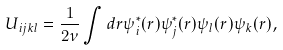Convert formula to latex. <formula><loc_0><loc_0><loc_500><loc_500>U _ { i j k l } = \frac { 1 } { 2 \nu } \int d { r } \psi _ { i } ^ { * } ( { r } ) \psi _ { j } ^ { * } ( { r } ) \psi _ { l } ( { r } ) \psi _ { k } ( { r } ) ,</formula> 